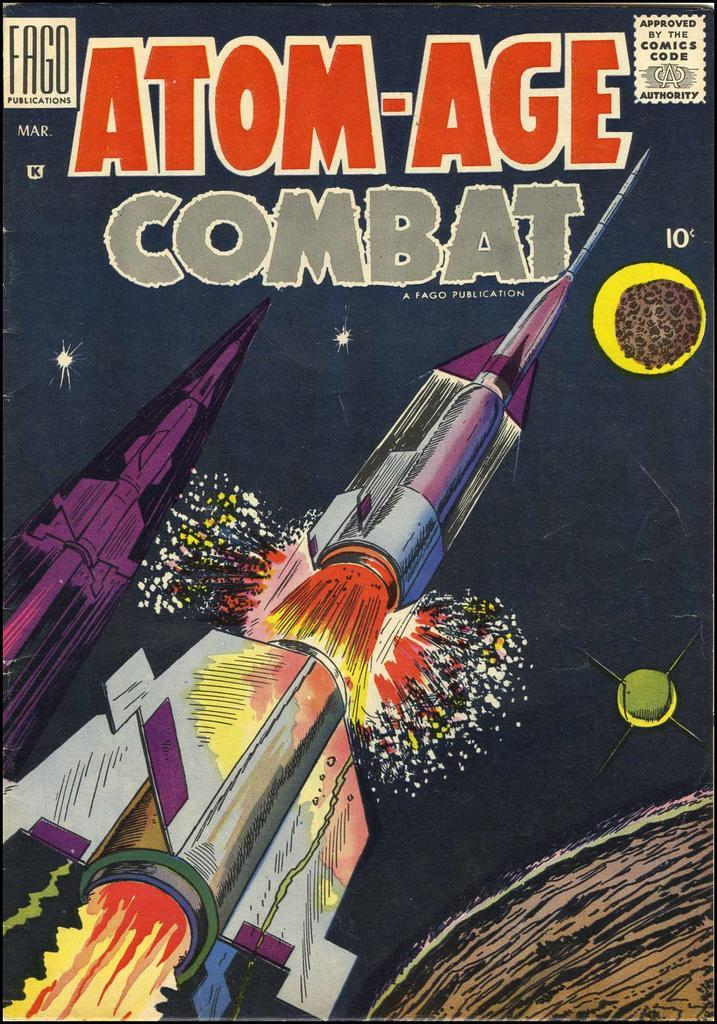<image>
Share a concise interpretation of the image provided. A comic book about the atomic age of combat showing a rocket launching. 